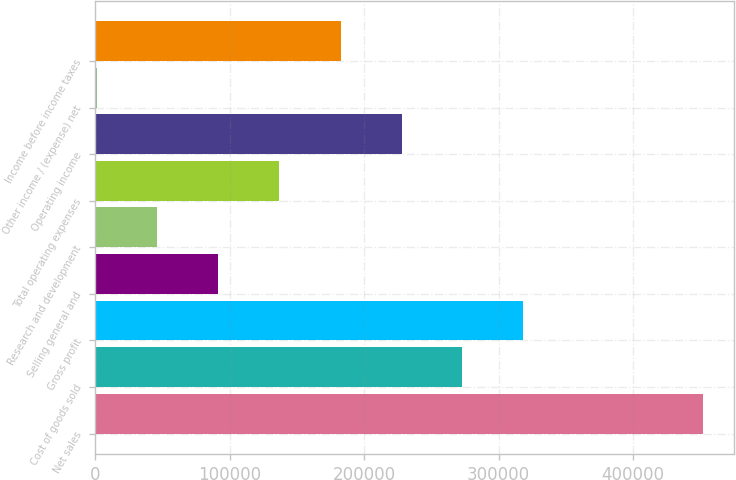<chart> <loc_0><loc_0><loc_500><loc_500><bar_chart><fcel>Net sales<fcel>Cost of goods sold<fcel>Gross profit<fcel>Selling general and<fcel>Research and development<fcel>Total operating expenses<fcel>Operating income<fcel>Other income / (expense) net<fcel>Income before income taxes<nl><fcel>452437<fcel>272960<fcel>318089<fcel>91402.6<fcel>46273.3<fcel>136532<fcel>227830<fcel>1144<fcel>182701<nl></chart> 